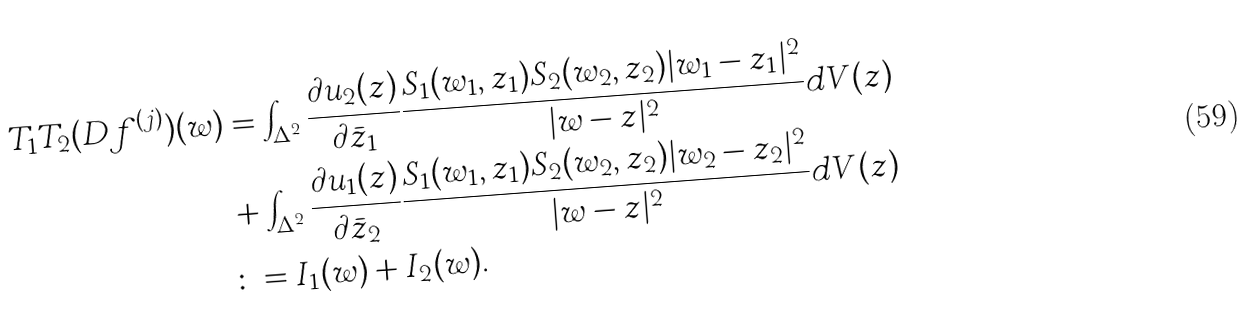Convert formula to latex. <formula><loc_0><loc_0><loc_500><loc_500>T _ { 1 } T _ { 2 } ( D f ^ { ( j ) } ) ( w ) & = \int _ { \Delta ^ { 2 } } \frac { \partial u _ { 2 } ( z ) } { \partial \bar { z } _ { 1 } } \frac { S _ { 1 } ( w _ { 1 } , z _ { 1 } ) S _ { 2 } ( w _ { 2 } , z _ { 2 } ) | w _ { 1 } - z _ { 1 } | ^ { 2 } } { | w - z | ^ { 2 } } d V ( z ) \\ & + \int _ { \Delta ^ { 2 } } \frac { \partial u _ { 1 } ( z ) } { \partial \bar { z } _ { 2 } } \frac { S _ { 1 } ( w _ { 1 } , z _ { 1 } ) S _ { 2 } ( w _ { 2 } , z _ { 2 } ) | w _ { 2 } - z _ { 2 } | ^ { 2 } } { | w - z | ^ { 2 } } d V ( z ) \\ & \colon = I _ { 1 } ( w ) + I _ { 2 } ( w ) .</formula> 